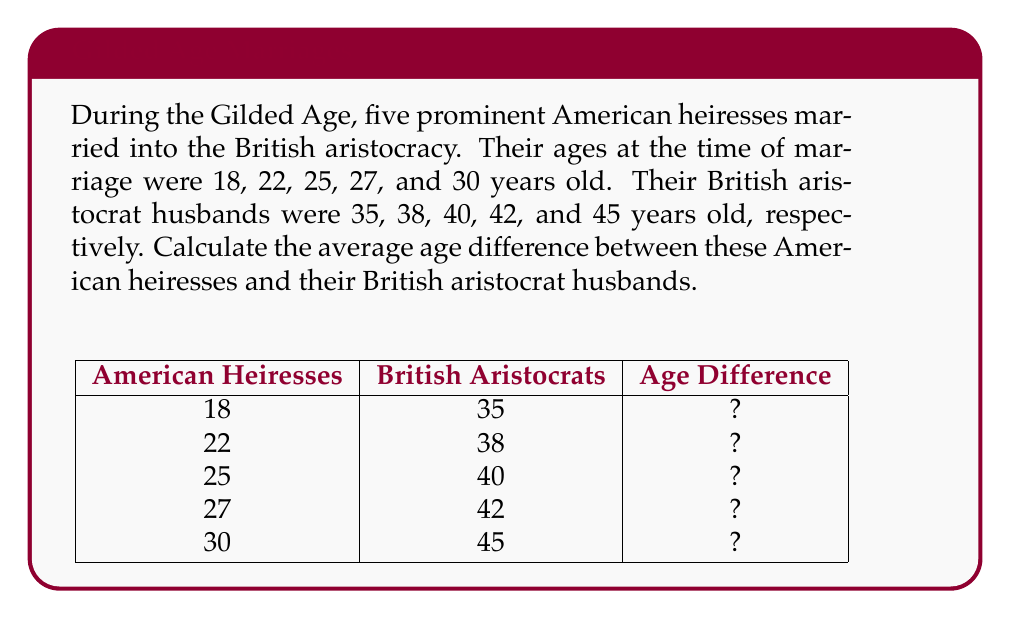What is the answer to this math problem? Let's approach this step-by-step:

1) First, we need to calculate the age difference for each couple:
   - Couple 1: $35 - 18 = 17$ years
   - Couple 2: $38 - 22 = 16$ years
   - Couple 3: $40 - 25 = 15$ years
   - Couple 4: $42 - 27 = 15$ years
   - Couple 5: $45 - 30 = 15$ years

2) Now, we have a set of age differences: 17, 16, 15, 15, 15

3) To calculate the average, we use the formula:
   
   $$ \text{Average} = \frac{\text{Sum of all values}}{\text{Number of values}} $$

4) Sum of all age differences:
   $17 + 16 + 15 + 15 + 15 = 78$ years

5) Number of couples: 5

6) Applying the formula:
   
   $$ \text{Average age difference} = \frac{78}{5} = 15.6 \text{ years} $$

Therefore, the average age difference between these American heiresses and their British aristocrat husbands is 15.6 years.
Answer: 15.6 years 